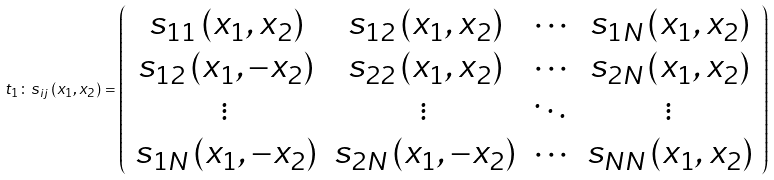<formula> <loc_0><loc_0><loc_500><loc_500>t _ { 1 } \colon s _ { i j } \left ( x _ { 1 } , x _ { 2 } \right ) = \left ( \begin{array} { c c c c } { { s _ { 1 1 } \left ( x _ { 1 } , x _ { 2 } \right ) } } & { { s _ { 1 2 } \left ( x _ { 1 } , x _ { 2 } \right ) } } & { \cdots } & { { s _ { 1 N } \left ( x _ { 1 } , x _ { 2 } \right ) } } \\ { { s _ { 1 2 } \left ( x _ { 1 } , - x _ { 2 } \right ) } } & { { s _ { 2 2 } \left ( x _ { 1 } , x _ { 2 } \right ) } } & { \cdots } & { { s _ { 2 N } \left ( x _ { 1 } , x _ { 2 } \right ) } } \\ { \vdots } & { \vdots } & { \ddots } & { \vdots } \\ { { s _ { 1 N } \left ( x _ { 1 } , - x _ { 2 } \right ) } } & { { s _ { 2 N } \left ( x _ { 1 } , - x _ { 2 } \right ) } } & { \cdots } & { { s _ { N N } \left ( x _ { 1 } , x _ { 2 } \right ) } } \end{array} \right )</formula> 